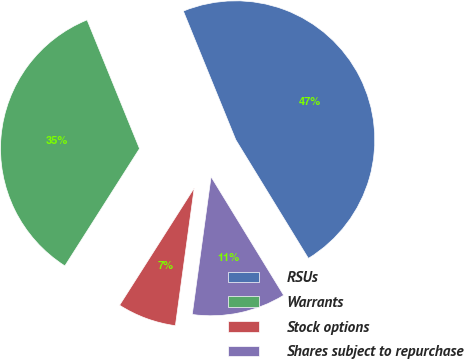Convert chart. <chart><loc_0><loc_0><loc_500><loc_500><pie_chart><fcel>RSUs<fcel>Warrants<fcel>Stock options<fcel>Shares subject to repurchase<nl><fcel>47.41%<fcel>34.82%<fcel>6.86%<fcel>10.91%<nl></chart> 